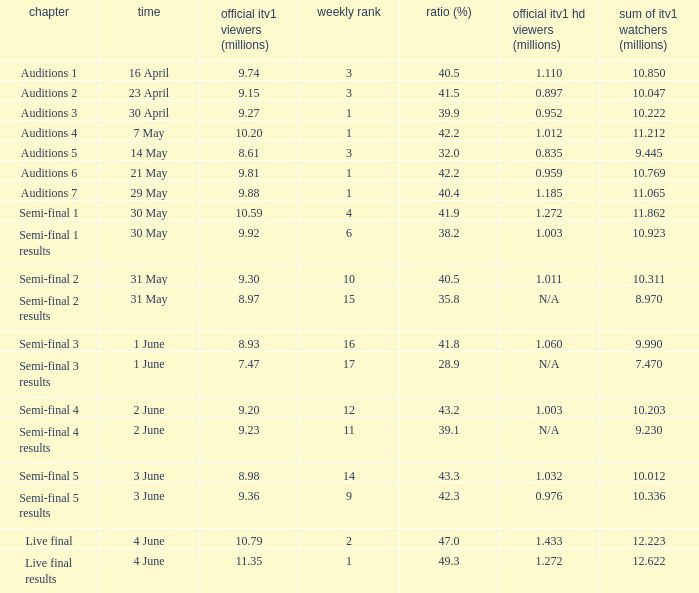What was the official ITV1 HD rating in millions for the episode that had an official ITV1 rating of 8.98 million? 1.032. 